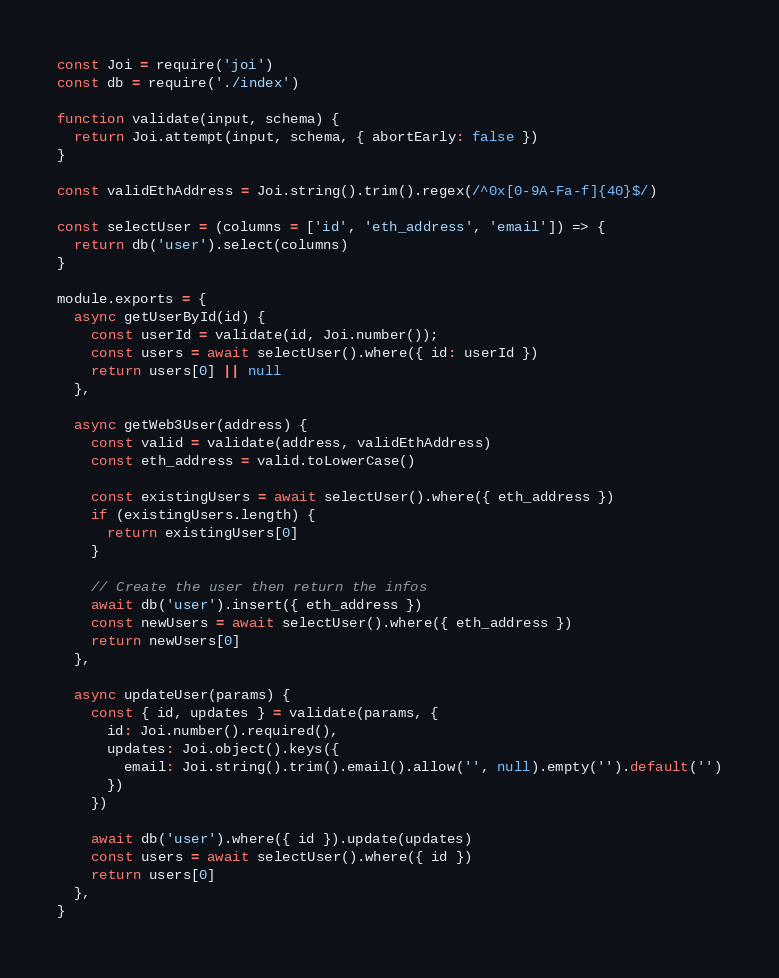<code> <loc_0><loc_0><loc_500><loc_500><_JavaScript_>const Joi = require('joi')
const db = require('./index')

function validate(input, schema) {
  return Joi.attempt(input, schema, { abortEarly: false })
}

const validEthAddress = Joi.string().trim().regex(/^0x[0-9A-Fa-f]{40}$/)

const selectUser = (columns = ['id', 'eth_address', 'email']) => {
  return db('user').select(columns)
}

module.exports = {
  async getUserById(id) {
    const userId = validate(id, Joi.number());
    const users = await selectUser().where({ id: userId })
    return users[0] || null
  },

  async getWeb3User(address) {
    const valid = validate(address, validEthAddress)
    const eth_address = valid.toLowerCase()

    const existingUsers = await selectUser().where({ eth_address })
    if (existingUsers.length) {
      return existingUsers[0]
    }

    // Create the user then return the infos
    await db('user').insert({ eth_address })
    const newUsers = await selectUser().where({ eth_address })
    return newUsers[0]
  },

  async updateUser(params) {
    const { id, updates } = validate(params, {
      id: Joi.number().required(),
      updates: Joi.object().keys({
        email: Joi.string().trim().email().allow('', null).empty('').default('')
      })
    })

    await db('user').where({ id }).update(updates)
    const users = await selectUser().where({ id })
    return users[0]
  },
}
</code> 